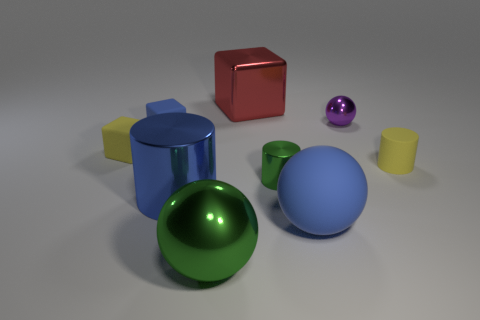Does the blue shiny object have the same shape as the small green metallic object? Yes, indeed. The blue shiny object and the small green metallic object both have a spherical shape, reflecting light similarly due to their polished, metallic surfaces which highlight their curvature and symmetry. 